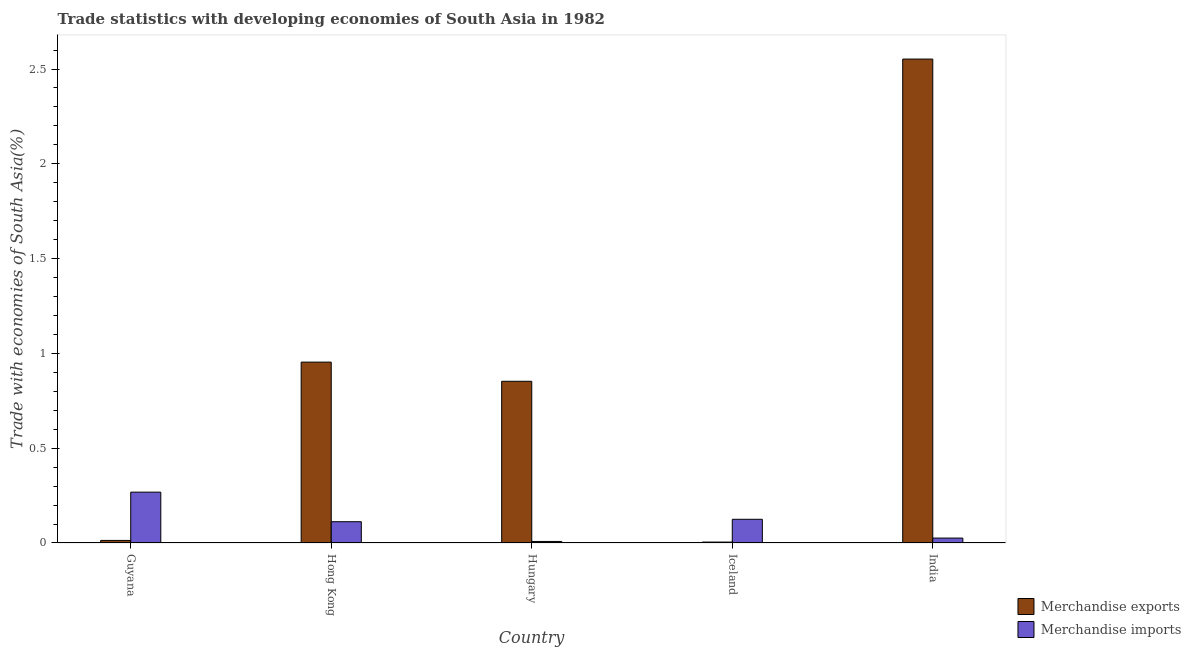How many different coloured bars are there?
Offer a very short reply. 2. Are the number of bars on each tick of the X-axis equal?
Ensure brevity in your answer.  Yes. How many bars are there on the 5th tick from the right?
Make the answer very short. 2. What is the label of the 5th group of bars from the left?
Provide a succinct answer. India. What is the merchandise exports in India?
Your answer should be very brief. 2.55. Across all countries, what is the maximum merchandise imports?
Ensure brevity in your answer.  0.27. Across all countries, what is the minimum merchandise exports?
Offer a terse response. 0. In which country was the merchandise exports maximum?
Your response must be concise. India. In which country was the merchandise imports minimum?
Keep it short and to the point. Hungary. What is the total merchandise exports in the graph?
Ensure brevity in your answer.  4.38. What is the difference between the merchandise exports in Hong Kong and that in Hungary?
Provide a short and direct response. 0.1. What is the difference between the merchandise imports in Guyana and the merchandise exports in Iceland?
Offer a terse response. 0.26. What is the average merchandise exports per country?
Your response must be concise. 0.88. What is the difference between the merchandise imports and merchandise exports in India?
Make the answer very short. -2.53. What is the ratio of the merchandise exports in Guyana to that in Iceland?
Your response must be concise. 2.81. Is the merchandise imports in Hungary less than that in Iceland?
Give a very brief answer. Yes. What is the difference between the highest and the second highest merchandise imports?
Give a very brief answer. 0.14. What is the difference between the highest and the lowest merchandise imports?
Keep it short and to the point. 0.26. What does the 2nd bar from the left in Iceland represents?
Make the answer very short. Merchandise imports. What does the 1st bar from the right in Hong Kong represents?
Make the answer very short. Merchandise imports. How many countries are there in the graph?
Ensure brevity in your answer.  5. Does the graph contain any zero values?
Give a very brief answer. No. Does the graph contain grids?
Provide a short and direct response. No. How many legend labels are there?
Your answer should be very brief. 2. What is the title of the graph?
Your response must be concise. Trade statistics with developing economies of South Asia in 1982. What is the label or title of the Y-axis?
Your response must be concise. Trade with economies of South Asia(%). What is the Trade with economies of South Asia(%) in Merchandise exports in Guyana?
Provide a short and direct response. 0.01. What is the Trade with economies of South Asia(%) in Merchandise imports in Guyana?
Make the answer very short. 0.27. What is the Trade with economies of South Asia(%) of Merchandise exports in Hong Kong?
Offer a very short reply. 0.95. What is the Trade with economies of South Asia(%) in Merchandise imports in Hong Kong?
Offer a terse response. 0.11. What is the Trade with economies of South Asia(%) in Merchandise exports in Hungary?
Make the answer very short. 0.85. What is the Trade with economies of South Asia(%) of Merchandise imports in Hungary?
Your response must be concise. 0.01. What is the Trade with economies of South Asia(%) in Merchandise exports in Iceland?
Keep it short and to the point. 0. What is the Trade with economies of South Asia(%) of Merchandise imports in Iceland?
Your response must be concise. 0.13. What is the Trade with economies of South Asia(%) in Merchandise exports in India?
Offer a terse response. 2.55. What is the Trade with economies of South Asia(%) in Merchandise imports in India?
Provide a short and direct response. 0.03. Across all countries, what is the maximum Trade with economies of South Asia(%) of Merchandise exports?
Ensure brevity in your answer.  2.55. Across all countries, what is the maximum Trade with economies of South Asia(%) of Merchandise imports?
Ensure brevity in your answer.  0.27. Across all countries, what is the minimum Trade with economies of South Asia(%) in Merchandise exports?
Keep it short and to the point. 0. Across all countries, what is the minimum Trade with economies of South Asia(%) of Merchandise imports?
Offer a terse response. 0.01. What is the total Trade with economies of South Asia(%) in Merchandise exports in the graph?
Offer a terse response. 4.38. What is the total Trade with economies of South Asia(%) in Merchandise imports in the graph?
Your response must be concise. 0.54. What is the difference between the Trade with economies of South Asia(%) in Merchandise exports in Guyana and that in Hong Kong?
Your response must be concise. -0.94. What is the difference between the Trade with economies of South Asia(%) of Merchandise imports in Guyana and that in Hong Kong?
Give a very brief answer. 0.16. What is the difference between the Trade with economies of South Asia(%) in Merchandise exports in Guyana and that in Hungary?
Offer a terse response. -0.84. What is the difference between the Trade with economies of South Asia(%) in Merchandise imports in Guyana and that in Hungary?
Give a very brief answer. 0.26. What is the difference between the Trade with economies of South Asia(%) of Merchandise exports in Guyana and that in Iceland?
Give a very brief answer. 0.01. What is the difference between the Trade with economies of South Asia(%) of Merchandise imports in Guyana and that in Iceland?
Make the answer very short. 0.14. What is the difference between the Trade with economies of South Asia(%) of Merchandise exports in Guyana and that in India?
Provide a short and direct response. -2.54. What is the difference between the Trade with economies of South Asia(%) in Merchandise imports in Guyana and that in India?
Offer a terse response. 0.24. What is the difference between the Trade with economies of South Asia(%) in Merchandise exports in Hong Kong and that in Hungary?
Provide a succinct answer. 0.1. What is the difference between the Trade with economies of South Asia(%) of Merchandise imports in Hong Kong and that in Hungary?
Offer a terse response. 0.1. What is the difference between the Trade with economies of South Asia(%) in Merchandise exports in Hong Kong and that in Iceland?
Provide a succinct answer. 0.95. What is the difference between the Trade with economies of South Asia(%) of Merchandise imports in Hong Kong and that in Iceland?
Your answer should be very brief. -0.01. What is the difference between the Trade with economies of South Asia(%) of Merchandise exports in Hong Kong and that in India?
Ensure brevity in your answer.  -1.6. What is the difference between the Trade with economies of South Asia(%) in Merchandise imports in Hong Kong and that in India?
Your answer should be very brief. 0.09. What is the difference between the Trade with economies of South Asia(%) in Merchandise exports in Hungary and that in Iceland?
Keep it short and to the point. 0.85. What is the difference between the Trade with economies of South Asia(%) in Merchandise imports in Hungary and that in Iceland?
Ensure brevity in your answer.  -0.12. What is the difference between the Trade with economies of South Asia(%) of Merchandise exports in Hungary and that in India?
Provide a short and direct response. -1.7. What is the difference between the Trade with economies of South Asia(%) in Merchandise imports in Hungary and that in India?
Your answer should be very brief. -0.02. What is the difference between the Trade with economies of South Asia(%) of Merchandise exports in Iceland and that in India?
Your response must be concise. -2.55. What is the difference between the Trade with economies of South Asia(%) of Merchandise imports in Iceland and that in India?
Provide a short and direct response. 0.1. What is the difference between the Trade with economies of South Asia(%) in Merchandise exports in Guyana and the Trade with economies of South Asia(%) in Merchandise imports in Hong Kong?
Your response must be concise. -0.1. What is the difference between the Trade with economies of South Asia(%) of Merchandise exports in Guyana and the Trade with economies of South Asia(%) of Merchandise imports in Hungary?
Offer a very short reply. 0.01. What is the difference between the Trade with economies of South Asia(%) of Merchandise exports in Guyana and the Trade with economies of South Asia(%) of Merchandise imports in Iceland?
Keep it short and to the point. -0.11. What is the difference between the Trade with economies of South Asia(%) in Merchandise exports in Guyana and the Trade with economies of South Asia(%) in Merchandise imports in India?
Provide a short and direct response. -0.01. What is the difference between the Trade with economies of South Asia(%) of Merchandise exports in Hong Kong and the Trade with economies of South Asia(%) of Merchandise imports in Hungary?
Keep it short and to the point. 0.95. What is the difference between the Trade with economies of South Asia(%) of Merchandise exports in Hong Kong and the Trade with economies of South Asia(%) of Merchandise imports in Iceland?
Offer a very short reply. 0.83. What is the difference between the Trade with economies of South Asia(%) of Merchandise exports in Hong Kong and the Trade with economies of South Asia(%) of Merchandise imports in India?
Give a very brief answer. 0.93. What is the difference between the Trade with economies of South Asia(%) in Merchandise exports in Hungary and the Trade with economies of South Asia(%) in Merchandise imports in Iceland?
Give a very brief answer. 0.73. What is the difference between the Trade with economies of South Asia(%) in Merchandise exports in Hungary and the Trade with economies of South Asia(%) in Merchandise imports in India?
Keep it short and to the point. 0.83. What is the difference between the Trade with economies of South Asia(%) of Merchandise exports in Iceland and the Trade with economies of South Asia(%) of Merchandise imports in India?
Your answer should be compact. -0.02. What is the average Trade with economies of South Asia(%) of Merchandise exports per country?
Offer a very short reply. 0.88. What is the average Trade with economies of South Asia(%) in Merchandise imports per country?
Keep it short and to the point. 0.11. What is the difference between the Trade with economies of South Asia(%) in Merchandise exports and Trade with economies of South Asia(%) in Merchandise imports in Guyana?
Ensure brevity in your answer.  -0.25. What is the difference between the Trade with economies of South Asia(%) of Merchandise exports and Trade with economies of South Asia(%) of Merchandise imports in Hong Kong?
Keep it short and to the point. 0.84. What is the difference between the Trade with economies of South Asia(%) in Merchandise exports and Trade with economies of South Asia(%) in Merchandise imports in Hungary?
Offer a terse response. 0.84. What is the difference between the Trade with economies of South Asia(%) in Merchandise exports and Trade with economies of South Asia(%) in Merchandise imports in Iceland?
Your response must be concise. -0.12. What is the difference between the Trade with economies of South Asia(%) of Merchandise exports and Trade with economies of South Asia(%) of Merchandise imports in India?
Keep it short and to the point. 2.53. What is the ratio of the Trade with economies of South Asia(%) in Merchandise exports in Guyana to that in Hong Kong?
Give a very brief answer. 0.01. What is the ratio of the Trade with economies of South Asia(%) of Merchandise imports in Guyana to that in Hong Kong?
Offer a terse response. 2.39. What is the ratio of the Trade with economies of South Asia(%) of Merchandise exports in Guyana to that in Hungary?
Your answer should be very brief. 0.02. What is the ratio of the Trade with economies of South Asia(%) of Merchandise imports in Guyana to that in Hungary?
Your answer should be very brief. 33.32. What is the ratio of the Trade with economies of South Asia(%) in Merchandise exports in Guyana to that in Iceland?
Give a very brief answer. 2.81. What is the ratio of the Trade with economies of South Asia(%) of Merchandise imports in Guyana to that in Iceland?
Give a very brief answer. 2.14. What is the ratio of the Trade with economies of South Asia(%) in Merchandise exports in Guyana to that in India?
Your response must be concise. 0.01. What is the ratio of the Trade with economies of South Asia(%) of Merchandise imports in Guyana to that in India?
Make the answer very short. 10.35. What is the ratio of the Trade with economies of South Asia(%) in Merchandise exports in Hong Kong to that in Hungary?
Ensure brevity in your answer.  1.12. What is the ratio of the Trade with economies of South Asia(%) of Merchandise imports in Hong Kong to that in Hungary?
Your response must be concise. 13.94. What is the ratio of the Trade with economies of South Asia(%) in Merchandise exports in Hong Kong to that in Iceland?
Make the answer very short. 198.15. What is the ratio of the Trade with economies of South Asia(%) of Merchandise imports in Hong Kong to that in Iceland?
Your answer should be compact. 0.9. What is the ratio of the Trade with economies of South Asia(%) in Merchandise exports in Hong Kong to that in India?
Offer a terse response. 0.37. What is the ratio of the Trade with economies of South Asia(%) in Merchandise imports in Hong Kong to that in India?
Ensure brevity in your answer.  4.33. What is the ratio of the Trade with economies of South Asia(%) of Merchandise exports in Hungary to that in Iceland?
Your answer should be compact. 177.15. What is the ratio of the Trade with economies of South Asia(%) in Merchandise imports in Hungary to that in Iceland?
Make the answer very short. 0.06. What is the ratio of the Trade with economies of South Asia(%) in Merchandise exports in Hungary to that in India?
Give a very brief answer. 0.33. What is the ratio of the Trade with economies of South Asia(%) of Merchandise imports in Hungary to that in India?
Make the answer very short. 0.31. What is the ratio of the Trade with economies of South Asia(%) in Merchandise exports in Iceland to that in India?
Your response must be concise. 0. What is the ratio of the Trade with economies of South Asia(%) of Merchandise imports in Iceland to that in India?
Provide a succinct answer. 4.82. What is the difference between the highest and the second highest Trade with economies of South Asia(%) in Merchandise exports?
Your answer should be very brief. 1.6. What is the difference between the highest and the second highest Trade with economies of South Asia(%) in Merchandise imports?
Ensure brevity in your answer.  0.14. What is the difference between the highest and the lowest Trade with economies of South Asia(%) of Merchandise exports?
Your answer should be compact. 2.55. What is the difference between the highest and the lowest Trade with economies of South Asia(%) of Merchandise imports?
Give a very brief answer. 0.26. 